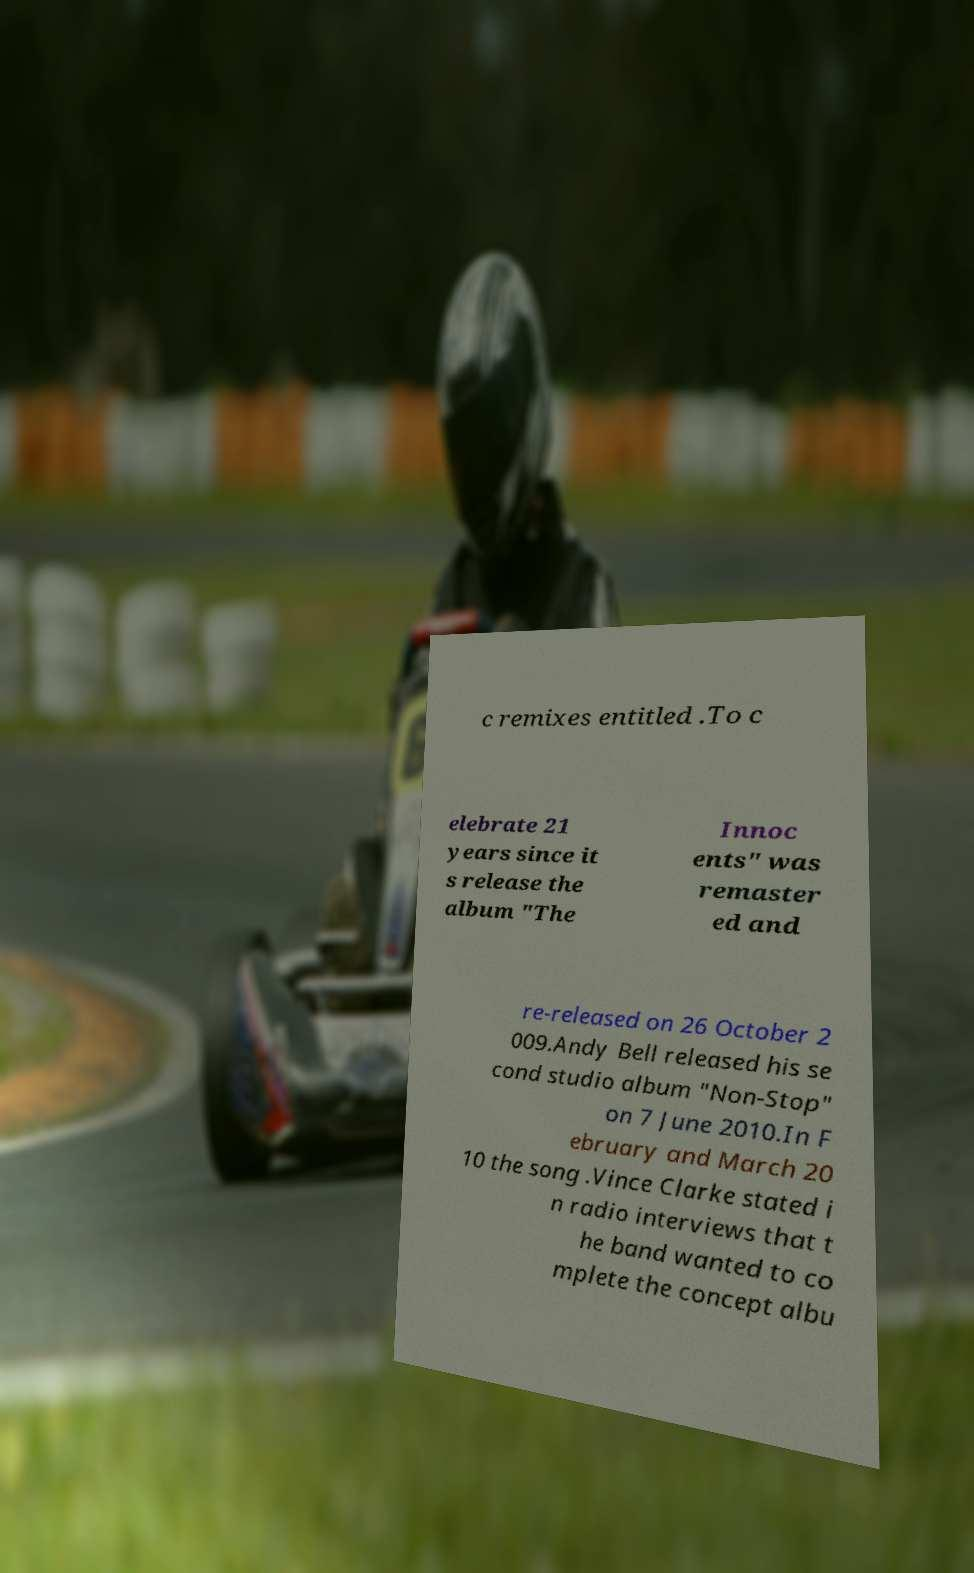Please identify and transcribe the text found in this image. c remixes entitled .To c elebrate 21 years since it s release the album "The Innoc ents" was remaster ed and re-released on 26 October 2 009.Andy Bell released his se cond studio album "Non-Stop" on 7 June 2010.In F ebruary and March 20 10 the song .Vince Clarke stated i n radio interviews that t he band wanted to co mplete the concept albu 